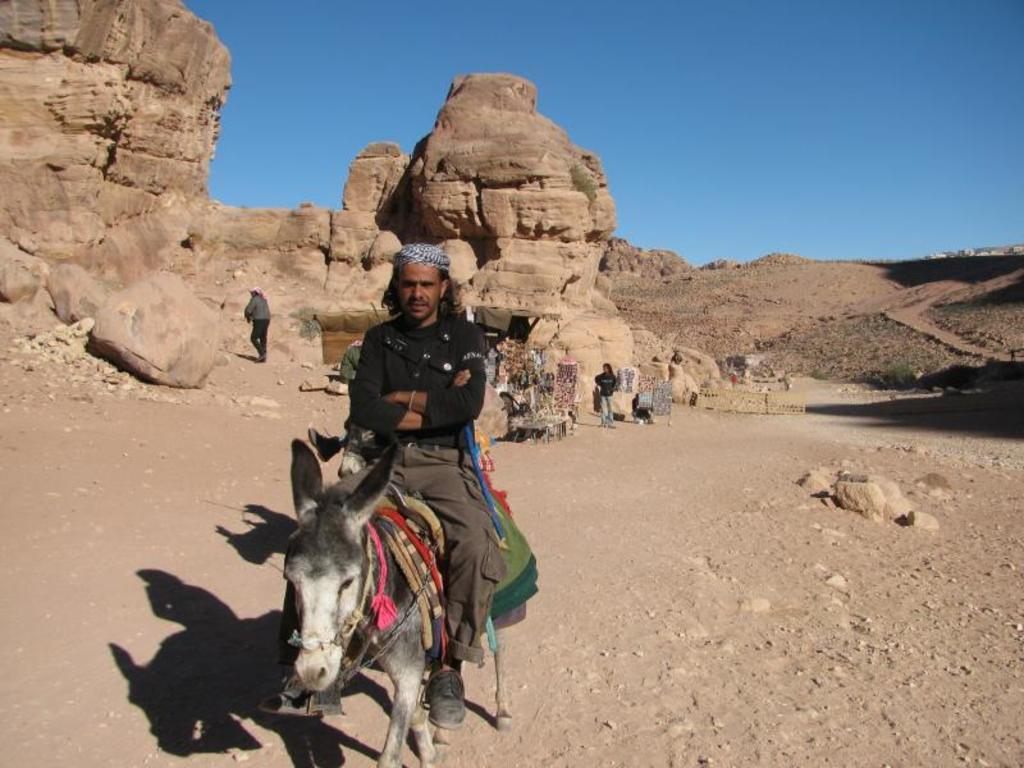What is the person in the image doing? The person is sitting on a donkey in the image. Are there any other people present in the image? Yes, there are people standing behind the person on the donkey. What type of environment is depicted in the image? The image is set in a desert environment. What can be seen in the background of the image? Sand dunes are visible in the background of the image. What is visible above the people and donkey in the image? The sky is visible in the image. What type of collar is the donkey wearing in the image? There is no collar visible on the donkey in the image. How many legs does the wave have in the image? There are no waves present in the image, so it is not possible to determine the number of legs a wave might have. 